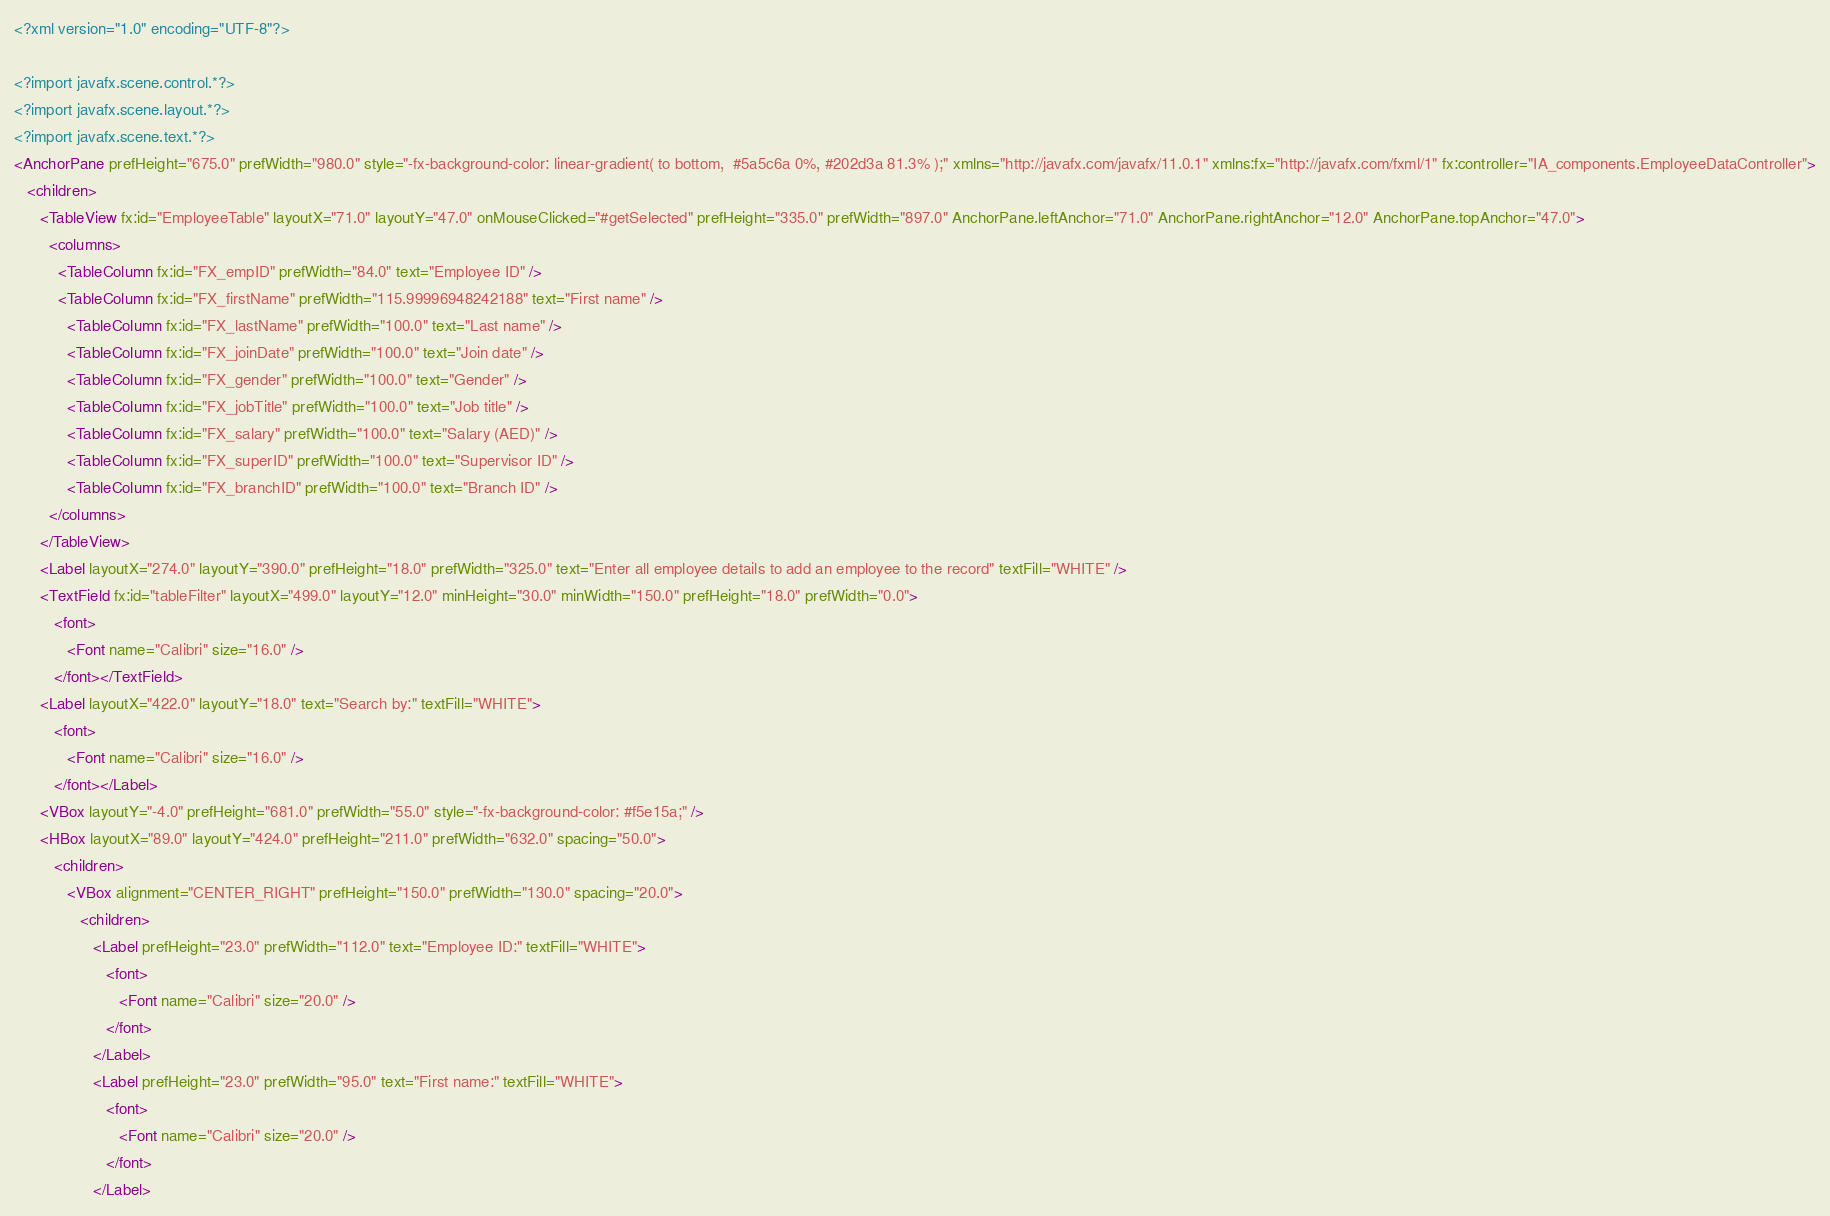<code> <loc_0><loc_0><loc_500><loc_500><_XML_><?xml version="1.0" encoding="UTF-8"?>

<?import javafx.scene.control.*?>
<?import javafx.scene.layout.*?>
<?import javafx.scene.text.*?>
<AnchorPane prefHeight="675.0" prefWidth="980.0" style="-fx-background-color: linear-gradient( to bottom,  #5a5c6a 0%, #202d3a 81.3% );" xmlns="http://javafx.com/javafx/11.0.1" xmlns:fx="http://javafx.com/fxml/1" fx:controller="IA_components.EmployeeDataController">
   <children>
      <TableView fx:id="EmployeeTable" layoutX="71.0" layoutY="47.0" onMouseClicked="#getSelected" prefHeight="335.0" prefWidth="897.0" AnchorPane.leftAnchor="71.0" AnchorPane.rightAnchor="12.0" AnchorPane.topAnchor="47.0">
        <columns>
          <TableColumn fx:id="FX_empID" prefWidth="84.0" text="Employee ID" />
          <TableColumn fx:id="FX_firstName" prefWidth="115.99996948242188" text="First name" />
            <TableColumn fx:id="FX_lastName" prefWidth="100.0" text="Last name" />
            <TableColumn fx:id="FX_joinDate" prefWidth="100.0" text="Join date" />
            <TableColumn fx:id="FX_gender" prefWidth="100.0" text="Gender" />
            <TableColumn fx:id="FX_jobTitle" prefWidth="100.0" text="Job title" />
            <TableColumn fx:id="FX_salary" prefWidth="100.0" text="Salary (AED)" />
            <TableColumn fx:id="FX_superID" prefWidth="100.0" text="Supervisor ID" />
            <TableColumn fx:id="FX_branchID" prefWidth="100.0" text="Branch ID" />
        </columns>
      </TableView>
      <Label layoutX="274.0" layoutY="390.0" prefHeight="18.0" prefWidth="325.0" text="Enter all employee details to add an employee to the record" textFill="WHITE" />
      <TextField fx:id="tableFilter" layoutX="499.0" layoutY="12.0" minHeight="30.0" minWidth="150.0" prefHeight="18.0" prefWidth="0.0">
         <font>
            <Font name="Calibri" size="16.0" />
         </font></TextField>
      <Label layoutX="422.0" layoutY="18.0" text="Search by:" textFill="WHITE">
         <font>
            <Font name="Calibri" size="16.0" />
         </font></Label>
      <VBox layoutY="-4.0" prefHeight="681.0" prefWidth="55.0" style="-fx-background-color: #f5e15a;" />
      <HBox layoutX="89.0" layoutY="424.0" prefHeight="211.0" prefWidth="632.0" spacing="50.0">
         <children>
            <VBox alignment="CENTER_RIGHT" prefHeight="150.0" prefWidth="130.0" spacing="20.0">
               <children>
                  <Label prefHeight="23.0" prefWidth="112.0" text="Employee ID:" textFill="WHITE">
                     <font>
                        <Font name="Calibri" size="20.0" />
                     </font>
                  </Label>
                  <Label prefHeight="23.0" prefWidth="95.0" text="First name:" textFill="WHITE">
                     <font>
                        <Font name="Calibri" size="20.0" />
                     </font>
                  </Label></code> 